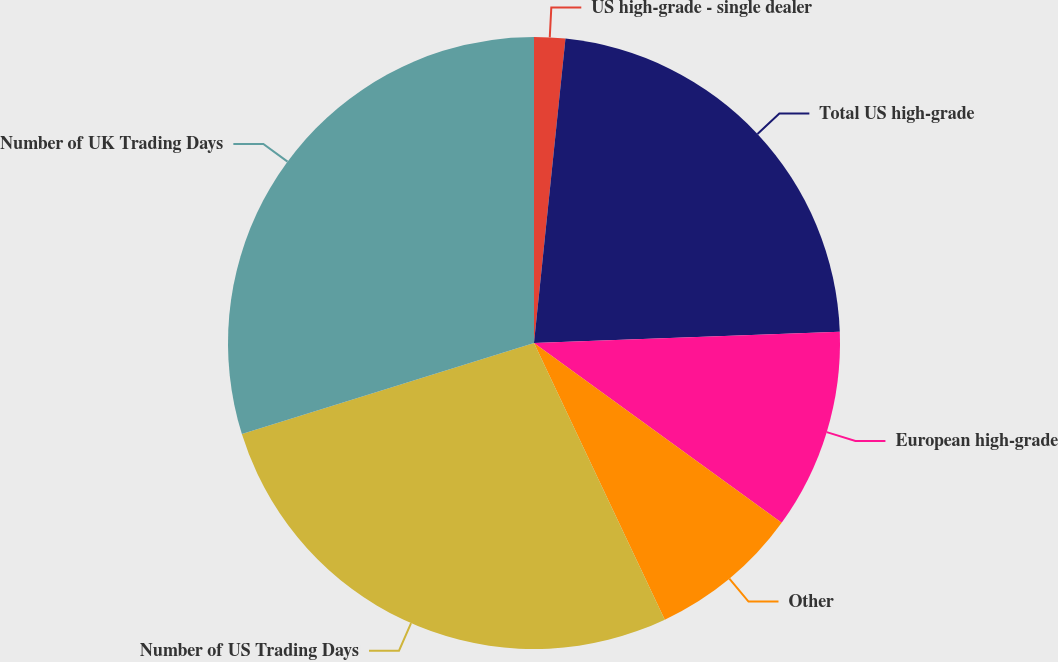Convert chart to OTSL. <chart><loc_0><loc_0><loc_500><loc_500><pie_chart><fcel>US high-grade - single dealer<fcel>Total US high-grade<fcel>European high-grade<fcel>Other<fcel>Number of US Trading Days<fcel>Number of UK Trading Days<nl><fcel>1.64%<fcel>22.78%<fcel>10.57%<fcel>7.98%<fcel>27.22%<fcel>29.81%<nl></chart> 